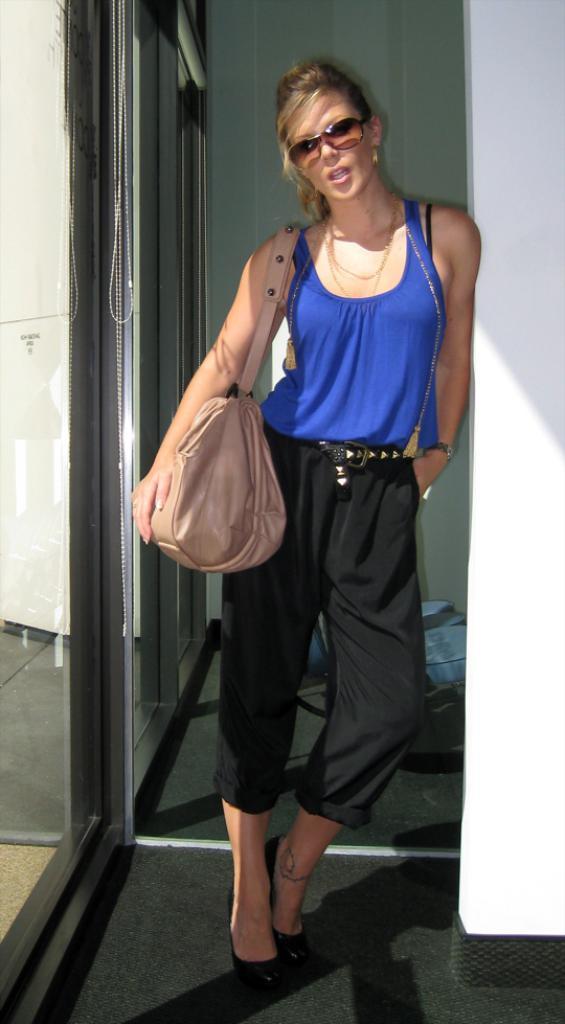Please provide a concise description of this image. In this image there is a woman she is wearing blue T-shirt, black pant, black heels, bag and spectacles, on the left there is a glass wall, on the right there is white wall. 